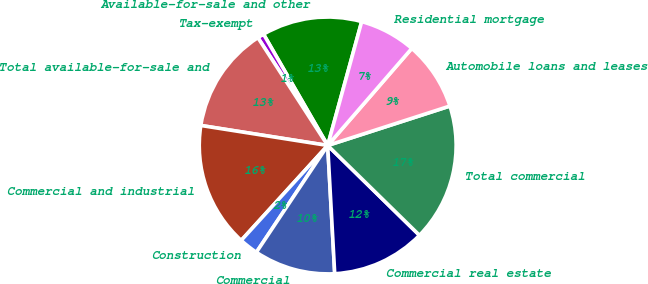Convert chart to OTSL. <chart><loc_0><loc_0><loc_500><loc_500><pie_chart><fcel>Available-for-sale and other<fcel>Tax-exempt<fcel>Total available-for-sale and<fcel>Commercial and industrial<fcel>Construction<fcel>Commercial<fcel>Commercial real estate<fcel>Total commercial<fcel>Automobile loans and leases<fcel>Residential mortgage<nl><fcel>12.59%<fcel>0.82%<fcel>13.37%<fcel>15.73%<fcel>2.39%<fcel>10.24%<fcel>11.8%<fcel>17.3%<fcel>8.67%<fcel>7.1%<nl></chart> 